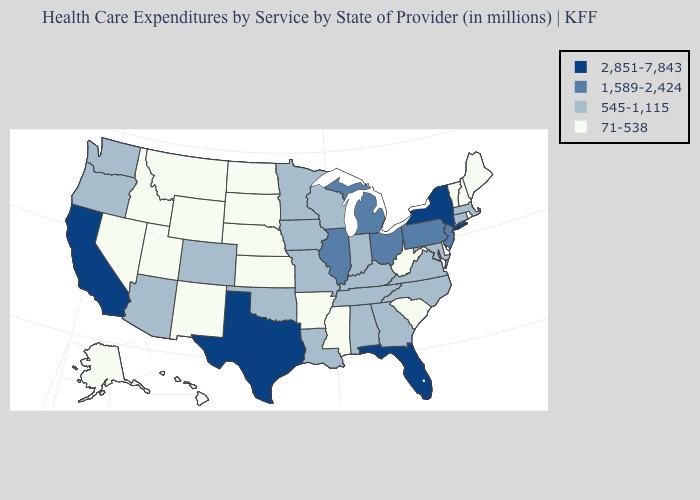Does Mississippi have the lowest value in the South?
Answer briefly. Yes. Which states have the lowest value in the South?
Quick response, please. Arkansas, Delaware, Mississippi, South Carolina, West Virginia. Name the states that have a value in the range 545-1,115?
Keep it brief. Alabama, Arizona, Colorado, Connecticut, Georgia, Indiana, Iowa, Kentucky, Louisiana, Maryland, Massachusetts, Minnesota, Missouri, North Carolina, Oklahoma, Oregon, Tennessee, Virginia, Washington, Wisconsin. Among the states that border New Mexico , does Colorado have the highest value?
Give a very brief answer. No. Which states have the lowest value in the South?
Short answer required. Arkansas, Delaware, Mississippi, South Carolina, West Virginia. What is the value of Kentucky?
Be succinct. 545-1,115. What is the lowest value in the MidWest?
Give a very brief answer. 71-538. Name the states that have a value in the range 71-538?
Answer briefly. Alaska, Arkansas, Delaware, Hawaii, Idaho, Kansas, Maine, Mississippi, Montana, Nebraska, Nevada, New Hampshire, New Mexico, North Dakota, Rhode Island, South Carolina, South Dakota, Utah, Vermont, West Virginia, Wyoming. Does the map have missing data?
Give a very brief answer. No. Name the states that have a value in the range 71-538?
Write a very short answer. Alaska, Arkansas, Delaware, Hawaii, Idaho, Kansas, Maine, Mississippi, Montana, Nebraska, Nevada, New Hampshire, New Mexico, North Dakota, Rhode Island, South Carolina, South Dakota, Utah, Vermont, West Virginia, Wyoming. What is the value of Maine?
Quick response, please. 71-538. Does New York have the highest value in the USA?
Write a very short answer. Yes. What is the highest value in the USA?
Write a very short answer. 2,851-7,843. Which states have the highest value in the USA?
Short answer required. California, Florida, New York, Texas. What is the value of Florida?
Quick response, please. 2,851-7,843. 